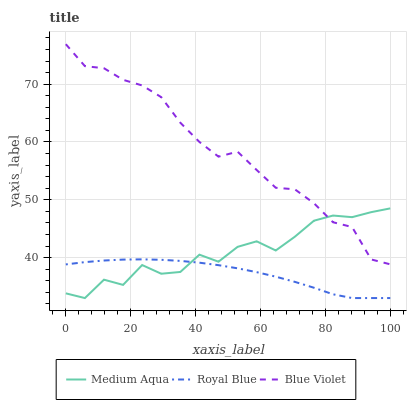Does Medium Aqua have the minimum area under the curve?
Answer yes or no. No. Does Medium Aqua have the maximum area under the curve?
Answer yes or no. No. Is Blue Violet the smoothest?
Answer yes or no. No. Is Blue Violet the roughest?
Answer yes or no. No. Does Blue Violet have the lowest value?
Answer yes or no. No. Does Medium Aqua have the highest value?
Answer yes or no. No. Is Royal Blue less than Blue Violet?
Answer yes or no. Yes. Is Blue Violet greater than Royal Blue?
Answer yes or no. Yes. Does Royal Blue intersect Blue Violet?
Answer yes or no. No. 